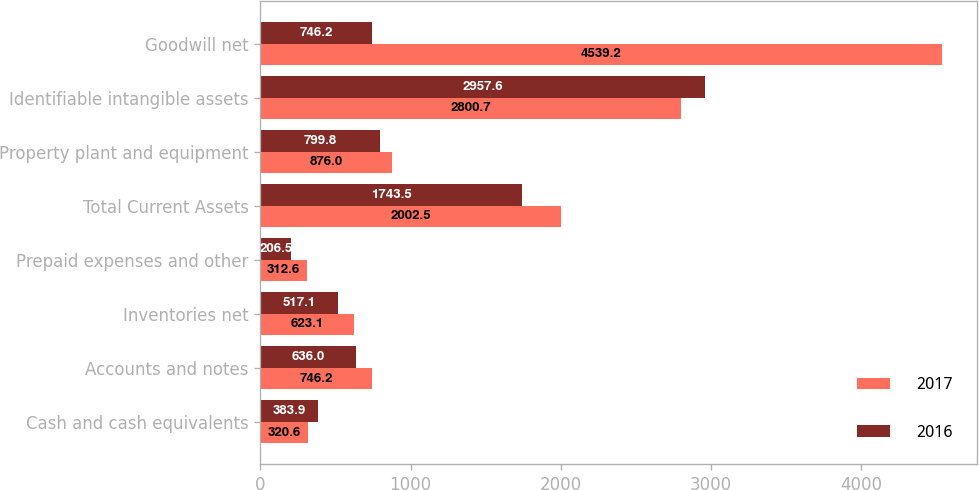Convert chart to OTSL. <chart><loc_0><loc_0><loc_500><loc_500><stacked_bar_chart><ecel><fcel>Cash and cash equivalents<fcel>Accounts and notes<fcel>Inventories net<fcel>Prepaid expenses and other<fcel>Total Current Assets<fcel>Property plant and equipment<fcel>Identifiable intangible assets<fcel>Goodwill net<nl><fcel>2017<fcel>320.6<fcel>746.2<fcel>623.1<fcel>312.6<fcel>2002.5<fcel>876<fcel>2800.7<fcel>4539.2<nl><fcel>2016<fcel>383.9<fcel>636<fcel>517.1<fcel>206.5<fcel>1743.5<fcel>799.8<fcel>2957.6<fcel>746.2<nl></chart> 